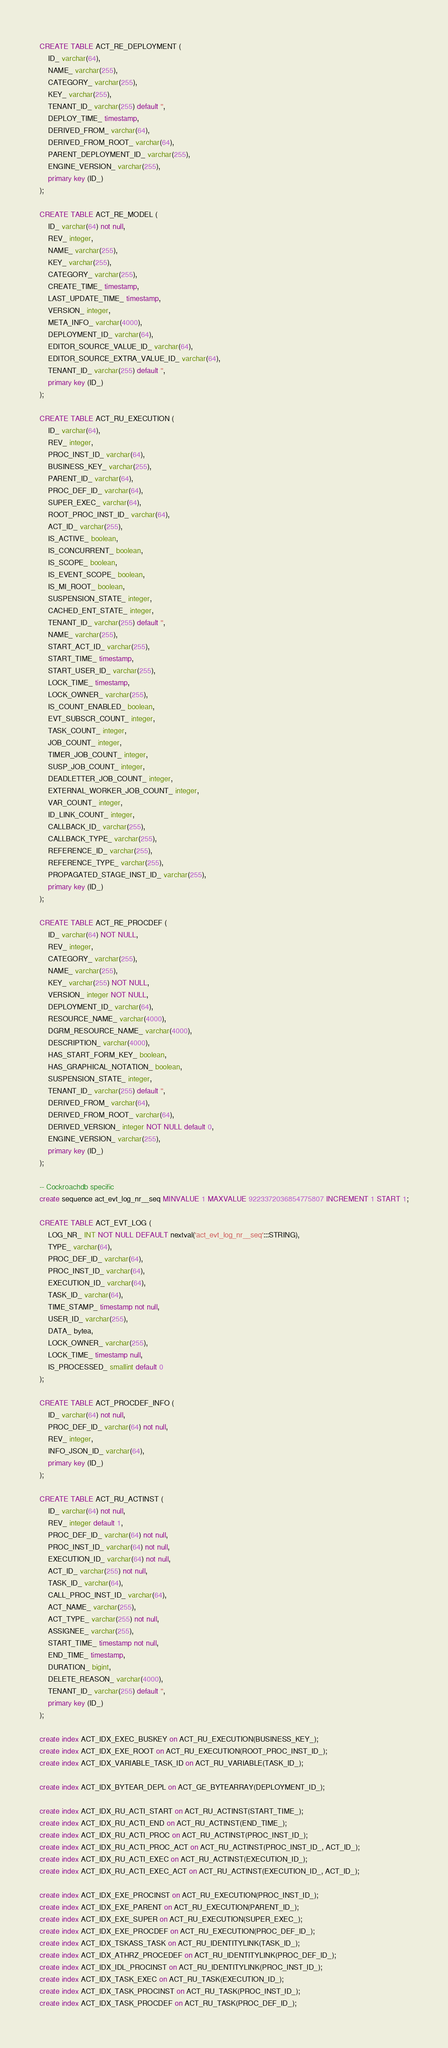<code> <loc_0><loc_0><loc_500><loc_500><_SQL_>CREATE TABLE ACT_RE_DEPLOYMENT (
    ID_ varchar(64),
    NAME_ varchar(255),
    CATEGORY_ varchar(255),
    KEY_ varchar(255),
    TENANT_ID_ varchar(255) default '',
    DEPLOY_TIME_ timestamp,
    DERIVED_FROM_ varchar(64),
    DERIVED_FROM_ROOT_ varchar(64),
    PARENT_DEPLOYMENT_ID_ varchar(255),
    ENGINE_VERSION_ varchar(255),
    primary key (ID_)
);

CREATE TABLE ACT_RE_MODEL (
    ID_ varchar(64) not null,
    REV_ integer,
    NAME_ varchar(255),
    KEY_ varchar(255),
    CATEGORY_ varchar(255),
    CREATE_TIME_ timestamp,
    LAST_UPDATE_TIME_ timestamp,
    VERSION_ integer,
    META_INFO_ varchar(4000),
    DEPLOYMENT_ID_ varchar(64),
    EDITOR_SOURCE_VALUE_ID_ varchar(64),
    EDITOR_SOURCE_EXTRA_VALUE_ID_ varchar(64),
    TENANT_ID_ varchar(255) default '',
    primary key (ID_)
);

CREATE TABLE ACT_RU_EXECUTION (
    ID_ varchar(64),
    REV_ integer,
    PROC_INST_ID_ varchar(64),
    BUSINESS_KEY_ varchar(255),
    PARENT_ID_ varchar(64),
    PROC_DEF_ID_ varchar(64),
    SUPER_EXEC_ varchar(64),
    ROOT_PROC_INST_ID_ varchar(64),
    ACT_ID_ varchar(255),
    IS_ACTIVE_ boolean,
    IS_CONCURRENT_ boolean,
    IS_SCOPE_ boolean,
    IS_EVENT_SCOPE_ boolean,
    IS_MI_ROOT_ boolean,
    SUSPENSION_STATE_ integer,
    CACHED_ENT_STATE_ integer,
    TENANT_ID_ varchar(255) default '',
    NAME_ varchar(255),
    START_ACT_ID_ varchar(255),
    START_TIME_ timestamp,
    START_USER_ID_ varchar(255),
    LOCK_TIME_ timestamp,
    LOCK_OWNER_ varchar(255),
    IS_COUNT_ENABLED_ boolean,
    EVT_SUBSCR_COUNT_ integer, 
    TASK_COUNT_ integer, 
    JOB_COUNT_ integer, 
    TIMER_JOB_COUNT_ integer,
    SUSP_JOB_COUNT_ integer,
    DEADLETTER_JOB_COUNT_ integer,
    EXTERNAL_WORKER_JOB_COUNT_ integer,
    VAR_COUNT_ integer, 
    ID_LINK_COUNT_ integer,
    CALLBACK_ID_ varchar(255),
    CALLBACK_TYPE_ varchar(255),
    REFERENCE_ID_ varchar(255),
    REFERENCE_TYPE_ varchar(255),
    PROPAGATED_STAGE_INST_ID_ varchar(255),
    primary key (ID_)
);

CREATE TABLE ACT_RE_PROCDEF (
    ID_ varchar(64) NOT NULL,
    REV_ integer,
    CATEGORY_ varchar(255),
    NAME_ varchar(255),
    KEY_ varchar(255) NOT NULL,
    VERSION_ integer NOT NULL,
    DEPLOYMENT_ID_ varchar(64),
    RESOURCE_NAME_ varchar(4000),
    DGRM_RESOURCE_NAME_ varchar(4000),
    DESCRIPTION_ varchar(4000),
    HAS_START_FORM_KEY_ boolean,
    HAS_GRAPHICAL_NOTATION_ boolean,
    SUSPENSION_STATE_ integer,
    TENANT_ID_ varchar(255) default '',
    DERIVED_FROM_ varchar(64),
    DERIVED_FROM_ROOT_ varchar(64),
    DERIVED_VERSION_ integer NOT NULL default 0,
    ENGINE_VERSION_ varchar(255),
    primary key (ID_)
);

-- Cockroachdb specific
create sequence act_evt_log_nr__seq MINVALUE 1 MAXVALUE 9223372036854775807 INCREMENT 1 START 1;

CREATE TABLE ACT_EVT_LOG (
    LOG_NR_ INT NOT NULL DEFAULT nextval('act_evt_log_nr__seq':::STRING),
    TYPE_ varchar(64),
    PROC_DEF_ID_ varchar(64),
    PROC_INST_ID_ varchar(64),
    EXECUTION_ID_ varchar(64),
    TASK_ID_ varchar(64),
    TIME_STAMP_ timestamp not null,
    USER_ID_ varchar(255),
    DATA_ bytea,
    LOCK_OWNER_ varchar(255),
    LOCK_TIME_ timestamp null,
    IS_PROCESSED_ smallint default 0
);

CREATE TABLE ACT_PROCDEF_INFO (
	ID_ varchar(64) not null,
    PROC_DEF_ID_ varchar(64) not null,
    REV_ integer,
    INFO_JSON_ID_ varchar(64),
    primary key (ID_)
);

CREATE TABLE ACT_RU_ACTINST (
    ID_ varchar(64) not null,
    REV_ integer default 1,
    PROC_DEF_ID_ varchar(64) not null,
    PROC_INST_ID_ varchar(64) not null,
    EXECUTION_ID_ varchar(64) not null,
    ACT_ID_ varchar(255) not null,
    TASK_ID_ varchar(64),
    CALL_PROC_INST_ID_ varchar(64),
    ACT_NAME_ varchar(255),
    ACT_TYPE_ varchar(255) not null,
    ASSIGNEE_ varchar(255),
    START_TIME_ timestamp not null,
    END_TIME_ timestamp,
    DURATION_ bigint,
    DELETE_REASON_ varchar(4000),
    TENANT_ID_ varchar(255) default '',
    primary key (ID_)
);

create index ACT_IDX_EXEC_BUSKEY on ACT_RU_EXECUTION(BUSINESS_KEY_);
create index ACT_IDX_EXE_ROOT on ACT_RU_EXECUTION(ROOT_PROC_INST_ID_);
create index ACT_IDX_VARIABLE_TASK_ID on ACT_RU_VARIABLE(TASK_ID_);

create index ACT_IDX_BYTEAR_DEPL on ACT_GE_BYTEARRAY(DEPLOYMENT_ID_);

create index ACT_IDX_RU_ACTI_START on ACT_RU_ACTINST(START_TIME_);
create index ACT_IDX_RU_ACTI_END on ACT_RU_ACTINST(END_TIME_);
create index ACT_IDX_RU_ACTI_PROC on ACT_RU_ACTINST(PROC_INST_ID_);
create index ACT_IDX_RU_ACTI_PROC_ACT on ACT_RU_ACTINST(PROC_INST_ID_, ACT_ID_);
create index ACT_IDX_RU_ACTI_EXEC on ACT_RU_ACTINST(EXECUTION_ID_);
create index ACT_IDX_RU_ACTI_EXEC_ACT on ACT_RU_ACTINST(EXECUTION_ID_, ACT_ID_);

create index ACT_IDX_EXE_PROCINST on ACT_RU_EXECUTION(PROC_INST_ID_);
create index ACT_IDX_EXE_PARENT on ACT_RU_EXECUTION(PARENT_ID_);
create index ACT_IDX_EXE_SUPER on ACT_RU_EXECUTION(SUPER_EXEC_);
create index ACT_IDX_EXE_PROCDEF on ACT_RU_EXECUTION(PROC_DEF_ID_);
create index ACT_IDX_TSKASS_TASK on ACT_RU_IDENTITYLINK(TASK_ID_);
create index ACT_IDX_ATHRZ_PROCEDEF on ACT_RU_IDENTITYLINK(PROC_DEF_ID_);
create index ACT_IDX_IDL_PROCINST on ACT_RU_IDENTITYLINK(PROC_INST_ID_);
create index ACT_IDX_TASK_EXEC on ACT_RU_TASK(EXECUTION_ID_);
create index ACT_IDX_TASK_PROCINST on ACT_RU_TASK(PROC_INST_ID_);
create index ACT_IDX_TASK_PROCDEF on ACT_RU_TASK(PROC_DEF_ID_);</code> 